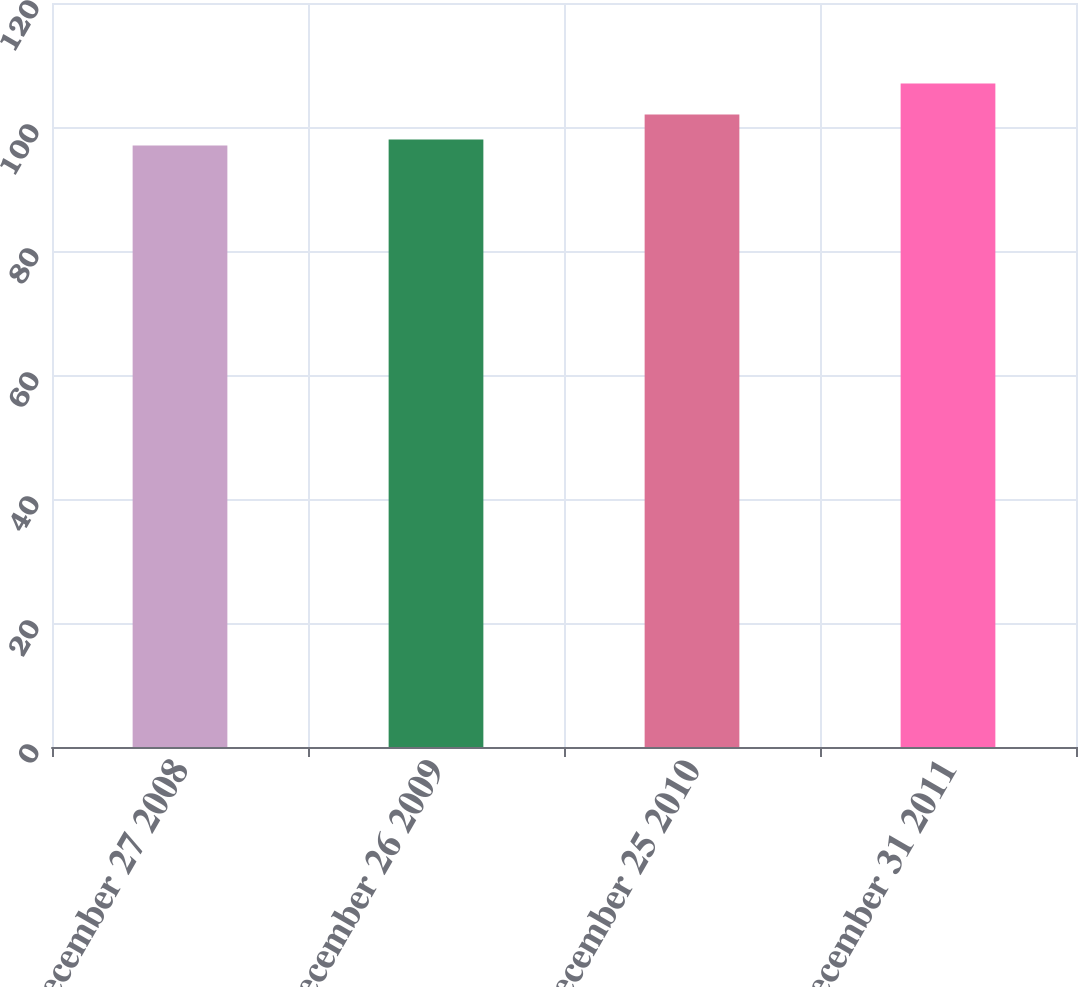Convert chart. <chart><loc_0><loc_0><loc_500><loc_500><bar_chart><fcel>December 27 2008<fcel>December 26 2009<fcel>December 25 2010<fcel>December 31 2011<nl><fcel>97<fcel>98<fcel>102<fcel>107<nl></chart> 